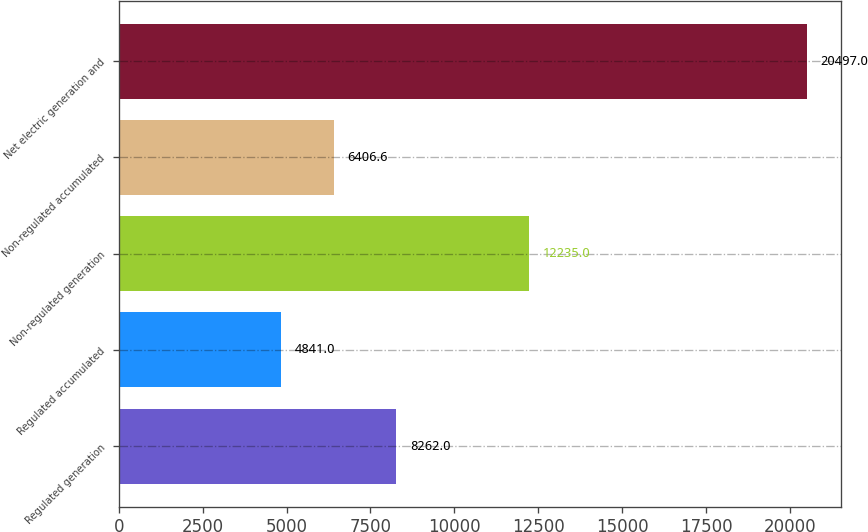Convert chart to OTSL. <chart><loc_0><loc_0><loc_500><loc_500><bar_chart><fcel>Regulated generation<fcel>Regulated accumulated<fcel>Non-regulated generation<fcel>Non-regulated accumulated<fcel>Net electric generation and<nl><fcel>8262<fcel>4841<fcel>12235<fcel>6406.6<fcel>20497<nl></chart> 